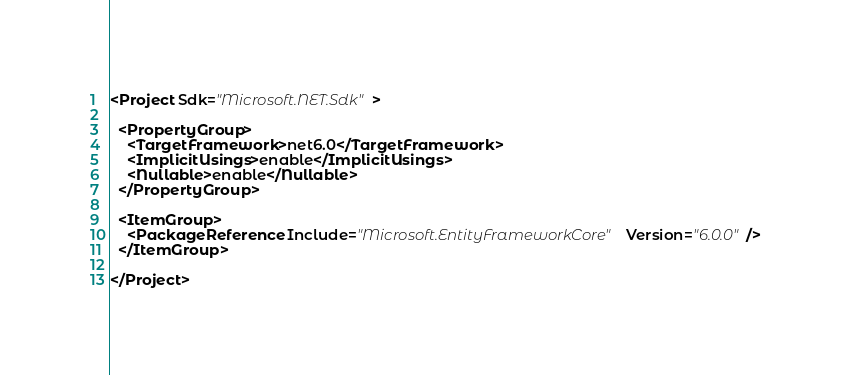Convert code to text. <code><loc_0><loc_0><loc_500><loc_500><_XML_><Project Sdk="Microsoft.NET.Sdk">

  <PropertyGroup>
    <TargetFramework>net6.0</TargetFramework>
    <ImplicitUsings>enable</ImplicitUsings>
    <Nullable>enable</Nullable>
  </PropertyGroup>

  <ItemGroup>
    <PackageReference Include="Microsoft.EntityFrameworkCore" Version="6.0.0" />
  </ItemGroup>

</Project>
</code> 